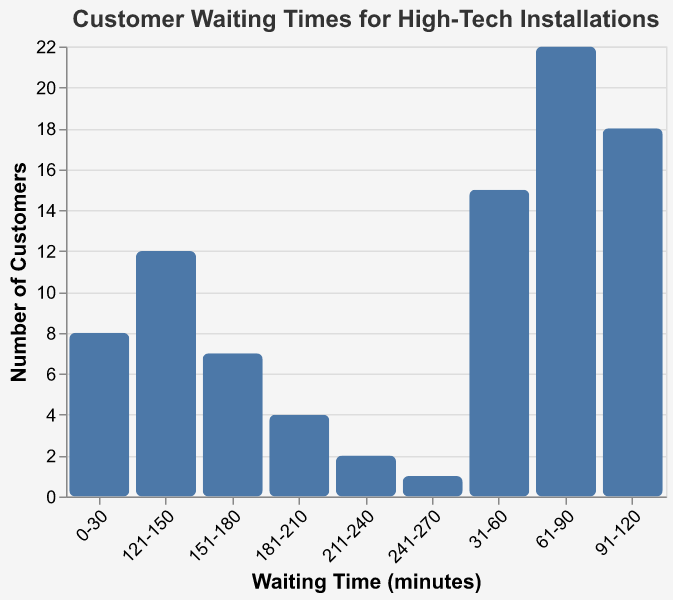What is the title of the figure? The title of the figure is displayed prominently at the top to provide context about the data being visualized.
Answer: Customer Waiting Times for High-Tech Installations What is the interval with the highest number of customers? Locate the tallest bar in the histogram, which shows the interval with the highest number of customers.
Answer: 61-90 minutes How many customers waited for 0-30 minutes? Find the number above the bar labeled "0-30" on the x-axis.
Answer: 8 What is the total number of customers who waited more than 120 minutes? Add the number of customers from all intervals greater than 120 minutes: 12 (121-150) + 7 (151-180) + 4 (181-210) + 2 (211-240) + 1 (241-270).
Answer: 26 Which interval has fewer customers: 121-150 minutes or 151-180 minutes? Compare the heights of the bars for the intervals 121-150 minutes and 151-180 minutes.
Answer: 151-180 minutes What is the average number of customers across all intervals? Sum the number of customers across all intervals and divide by the number of intervals: (8 + 15 + 22 + 18 + 12 + 7 + 4 + 2 + 1) / 9.
Answer: 9.89 Is the number of customers who waited between 91-120 minutes higher than the number of customers who waited between 31-60 minutes? Compare the heights of the bars for the intervals 91-120 minutes and 31-60 minutes.
Answer: Yes What is the cumulative number of customers who waited 90 minutes or less? Add the number of customers from the intervals 0-30, 31-60, and 61-90 minutes: 8 + 15 + 22.
Answer: 45 Which interval has the lowest number of customers? Locate the shortest bar in the histogram, which shows the interval with the lowest number of customers.
Answer: 241-270 minutes How many more customers waited between 61-90 minutes compared to 151-180 minutes? Subtract the number of customers in the 151-180 minutes interval from the number in the 61-90 minutes interval: 22 - 7.
Answer: 15 